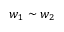<formula> <loc_0><loc_0><loc_500><loc_500>w _ { 1 } \sim w _ { 2 }</formula> 